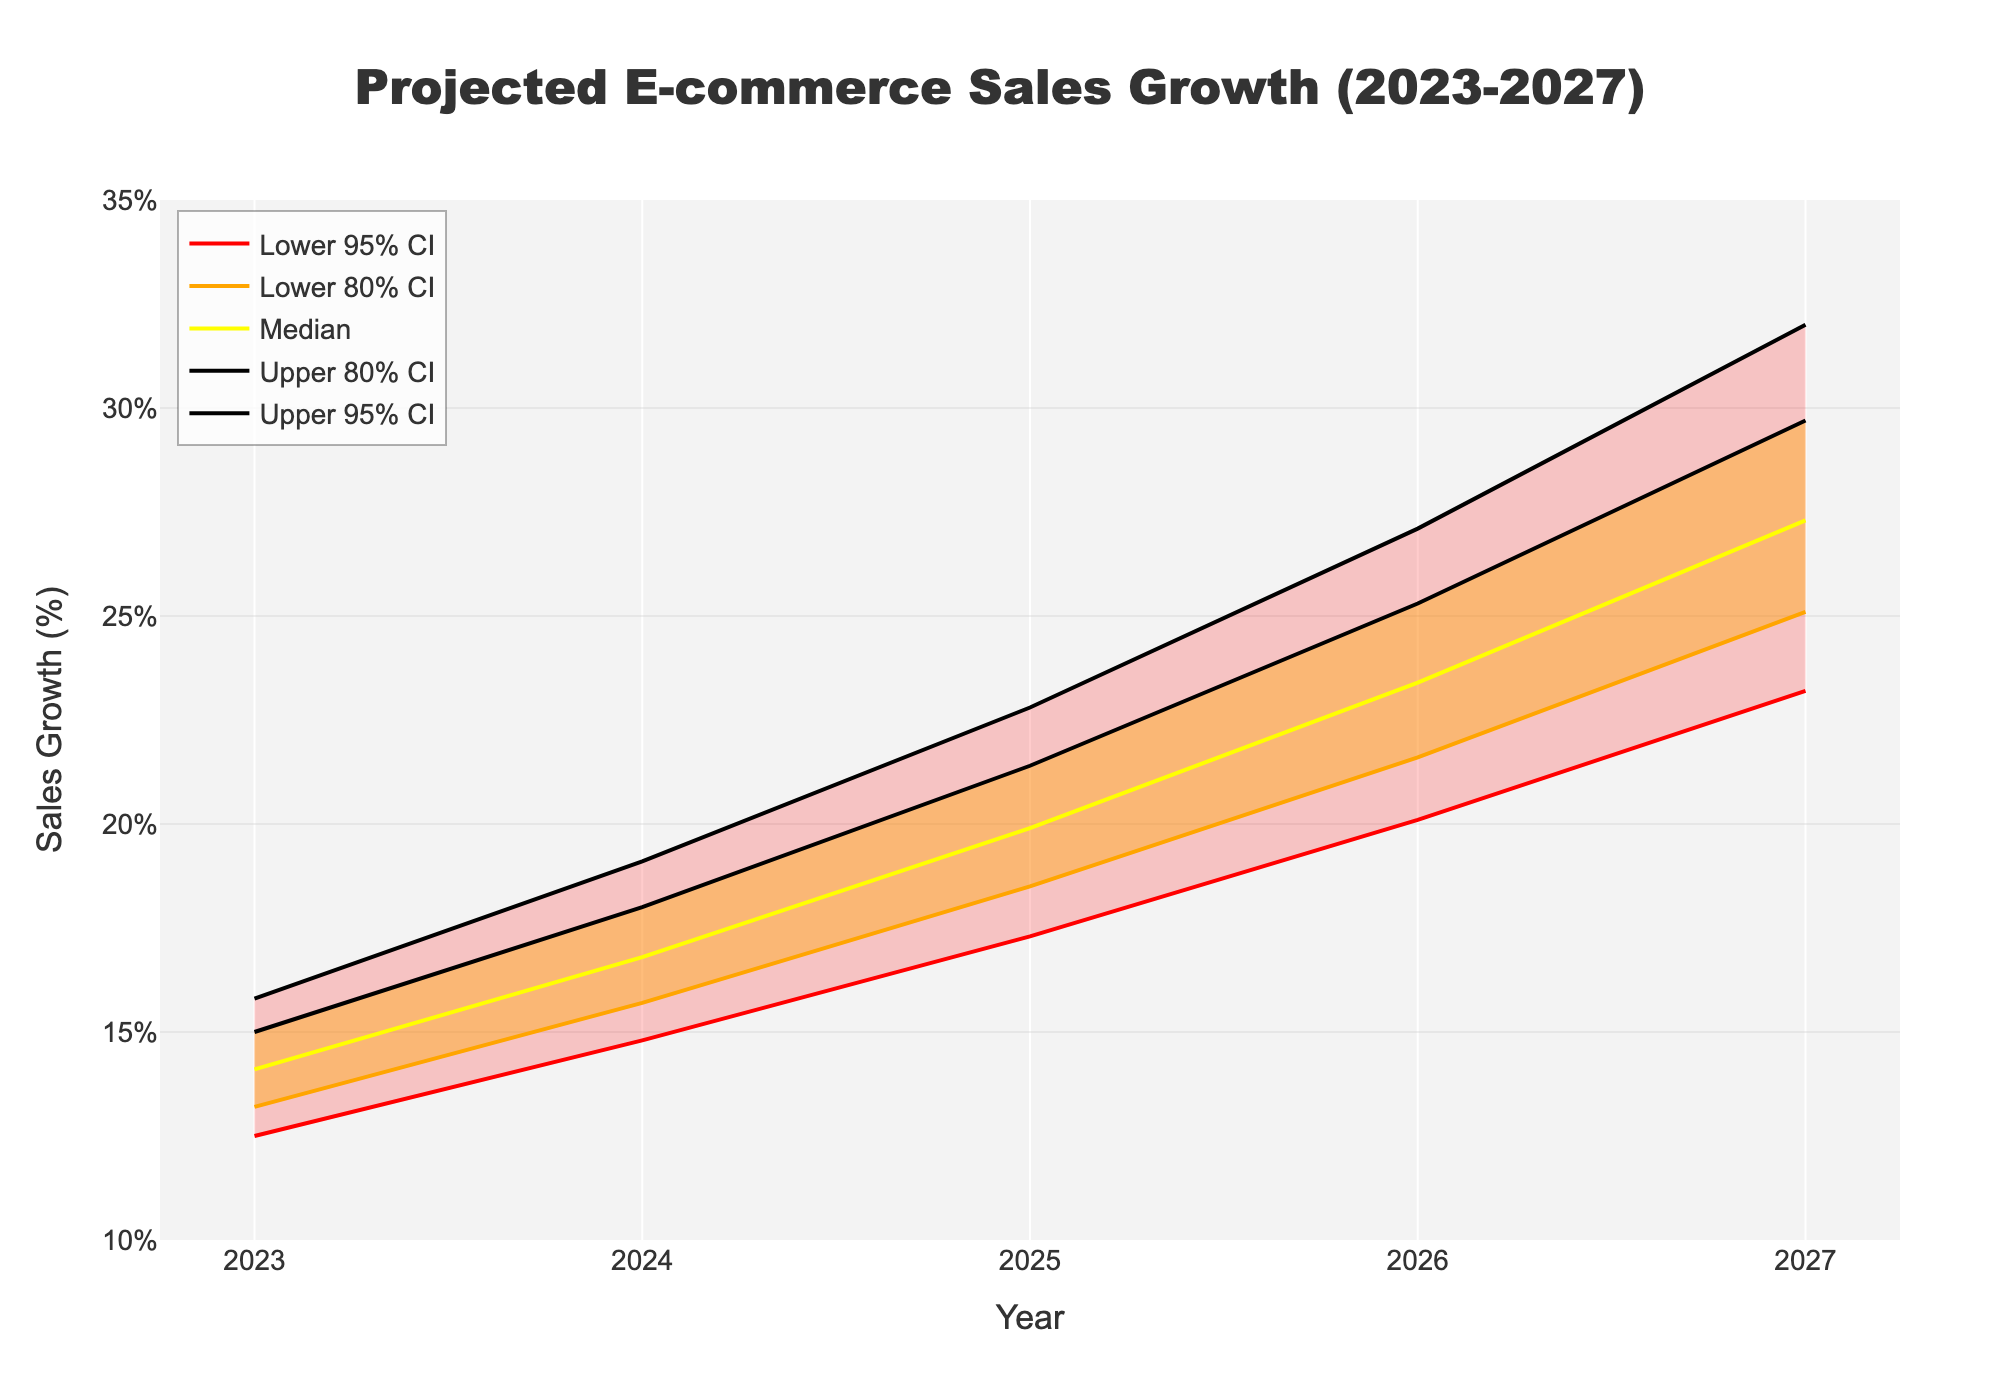How many years are displayed on the x-axis of the chart? The x-axis displays the years from 2023 to 2027. To determine the number of years, we simply count the years listed: 2023, 2024, 2025, 2026, 2027. This totals to 5 years.
Answer: 5 What is the projected median sales growth in 2026? According to the chart, the median projected sales growth for the year 2026 is specifically noted by the median line intersecting the value of 23.4% on the y-axis.
Answer: 23.4% Which year has the greatest increase in the median projected sales growth compared to the previous year? To find the year with the greatest increase, we look at the differences in median values year over year. From 2023 to 2024: 16.8% - 14.1% = 2.7%, from 2024 to 2025: 19.9% - 16.8% = 3.1%, from 2025 to 2026: 23.4% - 19.9% = 3.5%, and from 2026 to 2027: 27.3% - 23.4% = 3.9%. The largest difference of 3.9% is between 2026 and 2027.
Answer: 2027 What are the values of the lower and upper 80% confidence intervals for the year 2024? For the year 2024, the chart shows the lower 80% confidence interval at 15.7% and the upper 80% confidence interval at 18.0%.
Answer: 15.7%, 18.0% How wide is the range between the lower and upper 95% confidence intervals in 2025? The range is calculated by subtracting the lower 95% CI value from the upper 95% CI value for the year 2025. That is, 22.8% - 17.3% = 5.5%.
Answer: 5.5% Is the median projected sales growth increasing consistently every year? To determine if the median projected sales growth is increasing consistently, we compare the median values for each consecutive year: 2023 (14.1%), 2024 (16.8%), 2025 (19.9%), 2026 (23.4%), 2027 (27.3%). Each year's median value is higher than the previous year's, indicating a consistent increase.
Answer: Yes 